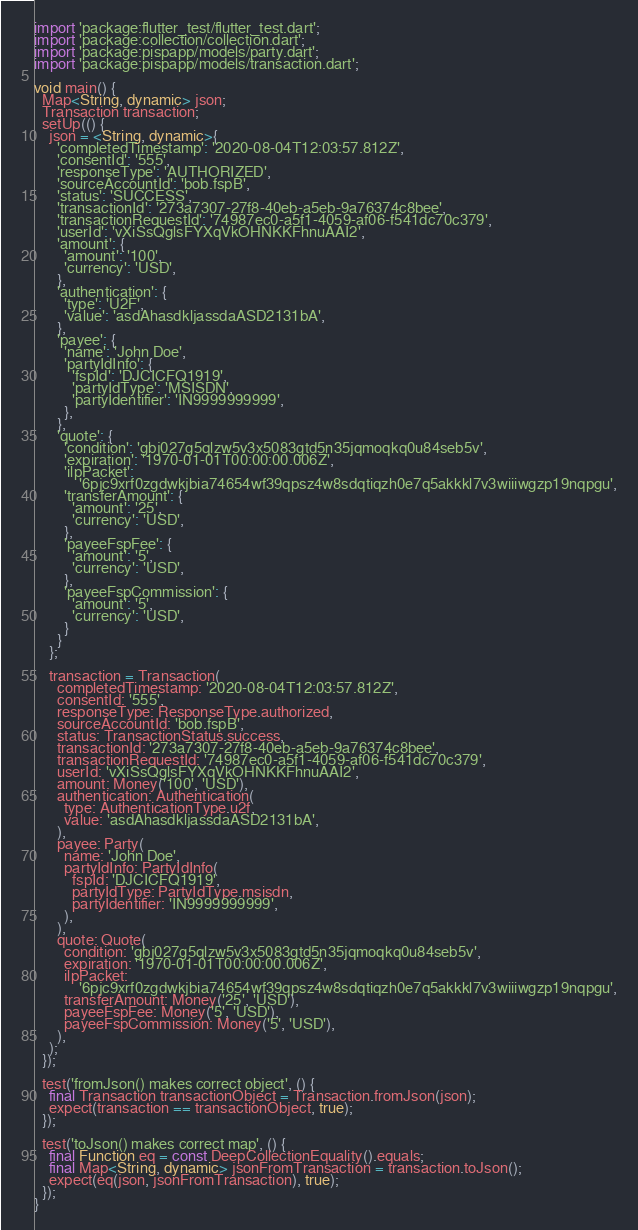<code> <loc_0><loc_0><loc_500><loc_500><_Dart_>import 'package:flutter_test/flutter_test.dart';
import 'package:collection/collection.dart';
import 'package:pispapp/models/party.dart';
import 'package:pispapp/models/transaction.dart';

void main() {
  Map<String, dynamic> json;
  Transaction transaction;
  setUp(() {
    json = <String, dynamic>{
      'completedTimestamp': '2020-08-04T12:03:57.812Z',
      'consentId': '555',
      'responseType': 'AUTHORIZED',
      'sourceAccountId': 'bob.fspB',
      'status': 'SUCCESS',
      'transactionId': '273a7307-27f8-40eb-a5eb-9a76374c8bee',
      'transactionRequestId': '74987ec0-a5f1-4059-af06-f541dc70c379',
      'userId': 'vXiSsQglsFYXqVkOHNKKFhnuAAI2',
      'amount': {
        'amount': '100',
        'currency': 'USD',
      },
      'authentication': {
        'type': 'U2F',
        'value': 'asdAhasdkljassdaASD2131bA',
      },
      'payee': {
        'name': 'John Doe',
        'partyIdInfo': {
          'fspId': 'DJCICFQ1919',
          'partyIdType': 'MSISDN',
          'partyIdentifier': 'IN9999999999',
        },
      },
      'quote': {
        'condition': 'gbj027g5qlzw5v3x5083gtd5n35jqmoqkq0u84seb5v',
        'expiration': '1970-01-01T00:00:00.006Z',
        'ilpPacket':
            '6pjc9xrf0zgdwkjbia74654wf39qpsz4w8sdqtiqzh0e7q5akkkl7v3wiiiwgzp19nqpgu',
        'transferAmount': {
          'amount': '25',
          'currency': 'USD',
        },
        'payeeFspFee': {
          'amount': '5',
          'currency': 'USD',
        },
        'payeeFspCommission': {
          'amount': '5',
          'currency': 'USD',
        }
      }
    };

    transaction = Transaction(
      completedTimestamp: '2020-08-04T12:03:57.812Z',
      consentId: '555',
      responseType: ResponseType.authorized,
      sourceAccountId: 'bob.fspB',
      status: TransactionStatus.success,
      transactionId: '273a7307-27f8-40eb-a5eb-9a76374c8bee',
      transactionRequestId: '74987ec0-a5f1-4059-af06-f541dc70c379',
      userId: 'vXiSsQglsFYXqVkOHNKKFhnuAAI2',
      amount: Money('100', 'USD'),
      authentication: Authentication(
        type: AuthenticationType.u2f,
        value: 'asdAhasdkljassdaASD2131bA',
      ),
      payee: Party(
        name: 'John Doe',
        partyIdInfo: PartyIdInfo(
          fspId: 'DJCICFQ1919',
          partyIdType: PartyIdType.msisdn,
          partyIdentifier: 'IN9999999999',
        ),
      ),
      quote: Quote(
        condition: 'gbj027g5qlzw5v3x5083gtd5n35jqmoqkq0u84seb5v',
        expiration: '1970-01-01T00:00:00.006Z',
        ilpPacket:
            '6pjc9xrf0zgdwkjbia74654wf39qpsz4w8sdqtiqzh0e7q5akkkl7v3wiiiwgzp19nqpgu',
        transferAmount: Money('25', 'USD'),
        payeeFspFee: Money('5', 'USD'),
        payeeFspCommission: Money('5', 'USD'),
      ),
    );
  });

  test('fromJson() makes correct object', () {
    final Transaction transactionObject = Transaction.fromJson(json);
    expect(transaction == transactionObject, true);
  });

  test('toJson() makes correct map', () {
    final Function eq = const DeepCollectionEquality().equals;
    final Map<String, dynamic> jsonFromTransaction = transaction.toJson();
    expect(eq(json, jsonFromTransaction), true);
  });
}
</code> 